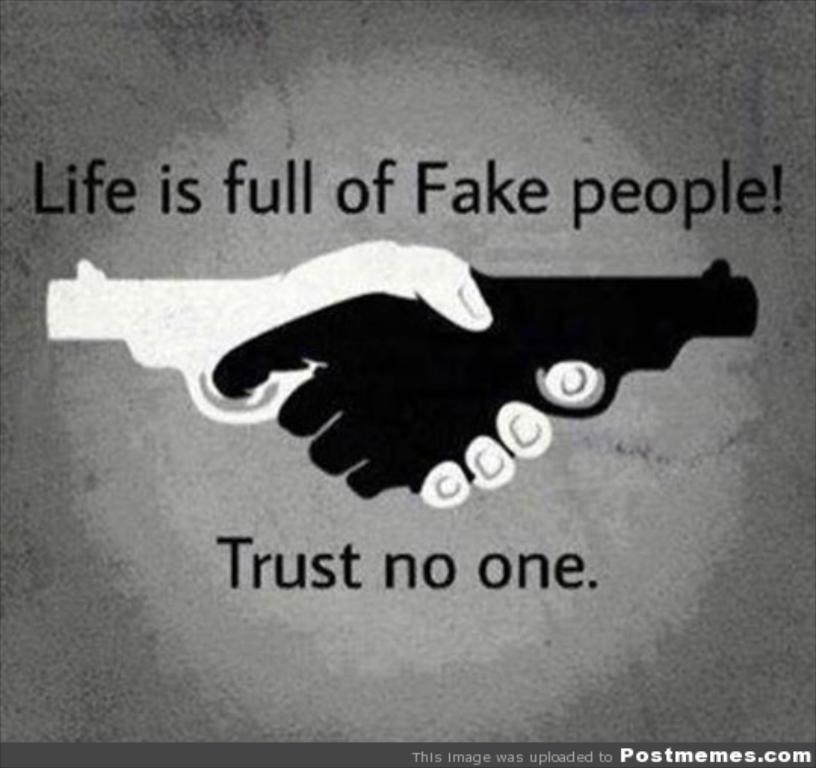What is life full of?
Keep it short and to the point. Fake people. Why should we not trust no one?
Give a very brief answer. Life is full of fake people. 